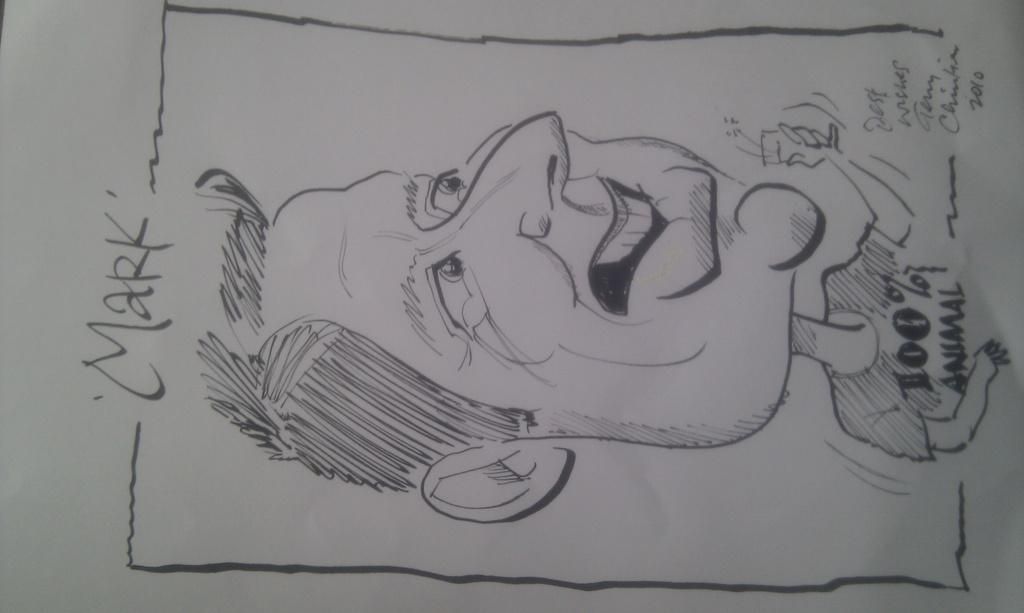What is the main subject in the center of the image? There is a sketch and text on a paper in the center of the image. Can you describe the sketch in the image? Unfortunately, the details of the sketch cannot be determined from the provided facts. What is written on the paper in the image? The content of the text on the paper cannot be determined from the provided facts. What type of thunder can be heard in the bedroom in the image? There is no mention of thunder or a bedroom in the image, so it is not possible to answer that question. 